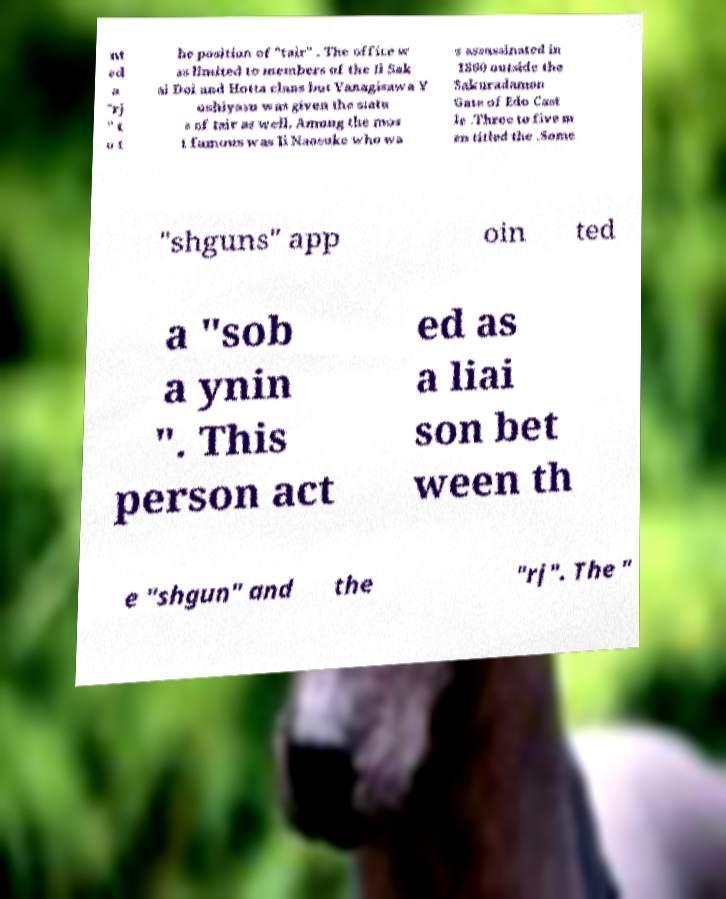There's text embedded in this image that I need extracted. Can you transcribe it verbatim? nt ed a "rj " t o t he position of "tair" . The office w as limited to members of the Ii Sak ai Doi and Hotta clans but Yanagisawa Y oshiyasu was given the statu s of tair as well. Among the mos t famous was Ii Naosuke who wa s assassinated in 1860 outside the Sakuradamon Gate of Edo Cast le .Three to five m en titled the .Some "shguns" app oin ted a "sob a ynin ". This person act ed as a liai son bet ween th e "shgun" and the "rj". The " 